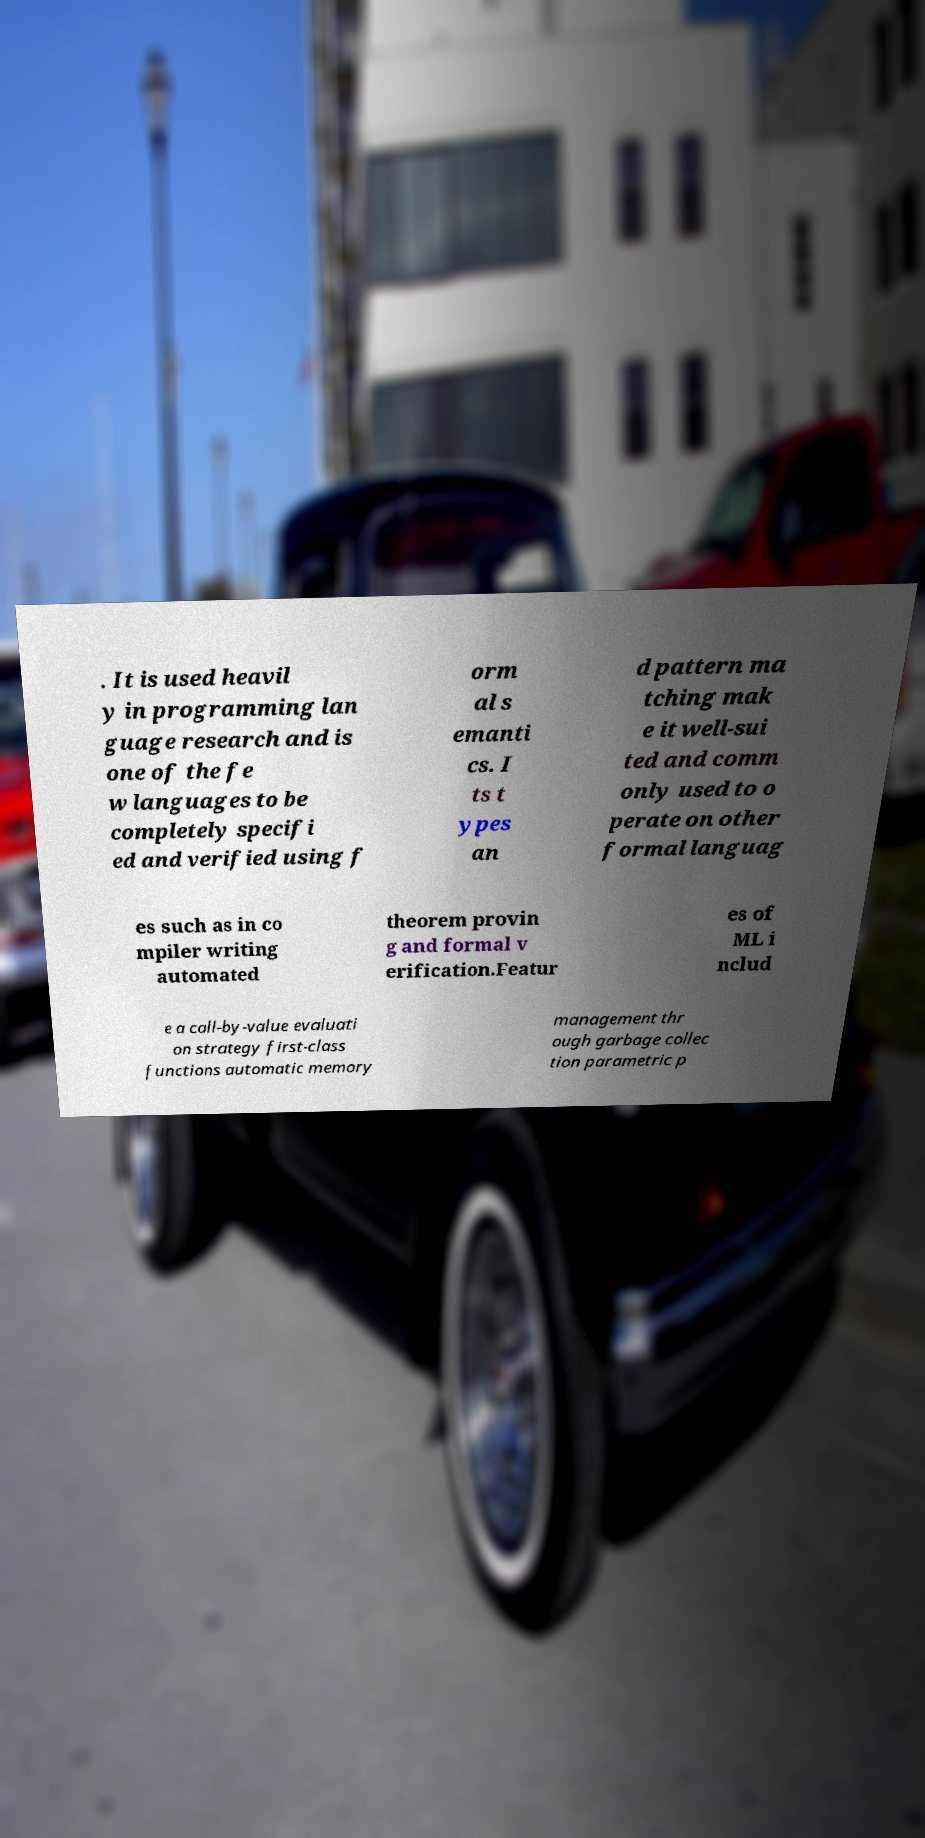There's text embedded in this image that I need extracted. Can you transcribe it verbatim? . It is used heavil y in programming lan guage research and is one of the fe w languages to be completely specifi ed and verified using f orm al s emanti cs. I ts t ypes an d pattern ma tching mak e it well-sui ted and comm only used to o perate on other formal languag es such as in co mpiler writing automated theorem provin g and formal v erification.Featur es of ML i nclud e a call-by-value evaluati on strategy first-class functions automatic memory management thr ough garbage collec tion parametric p 